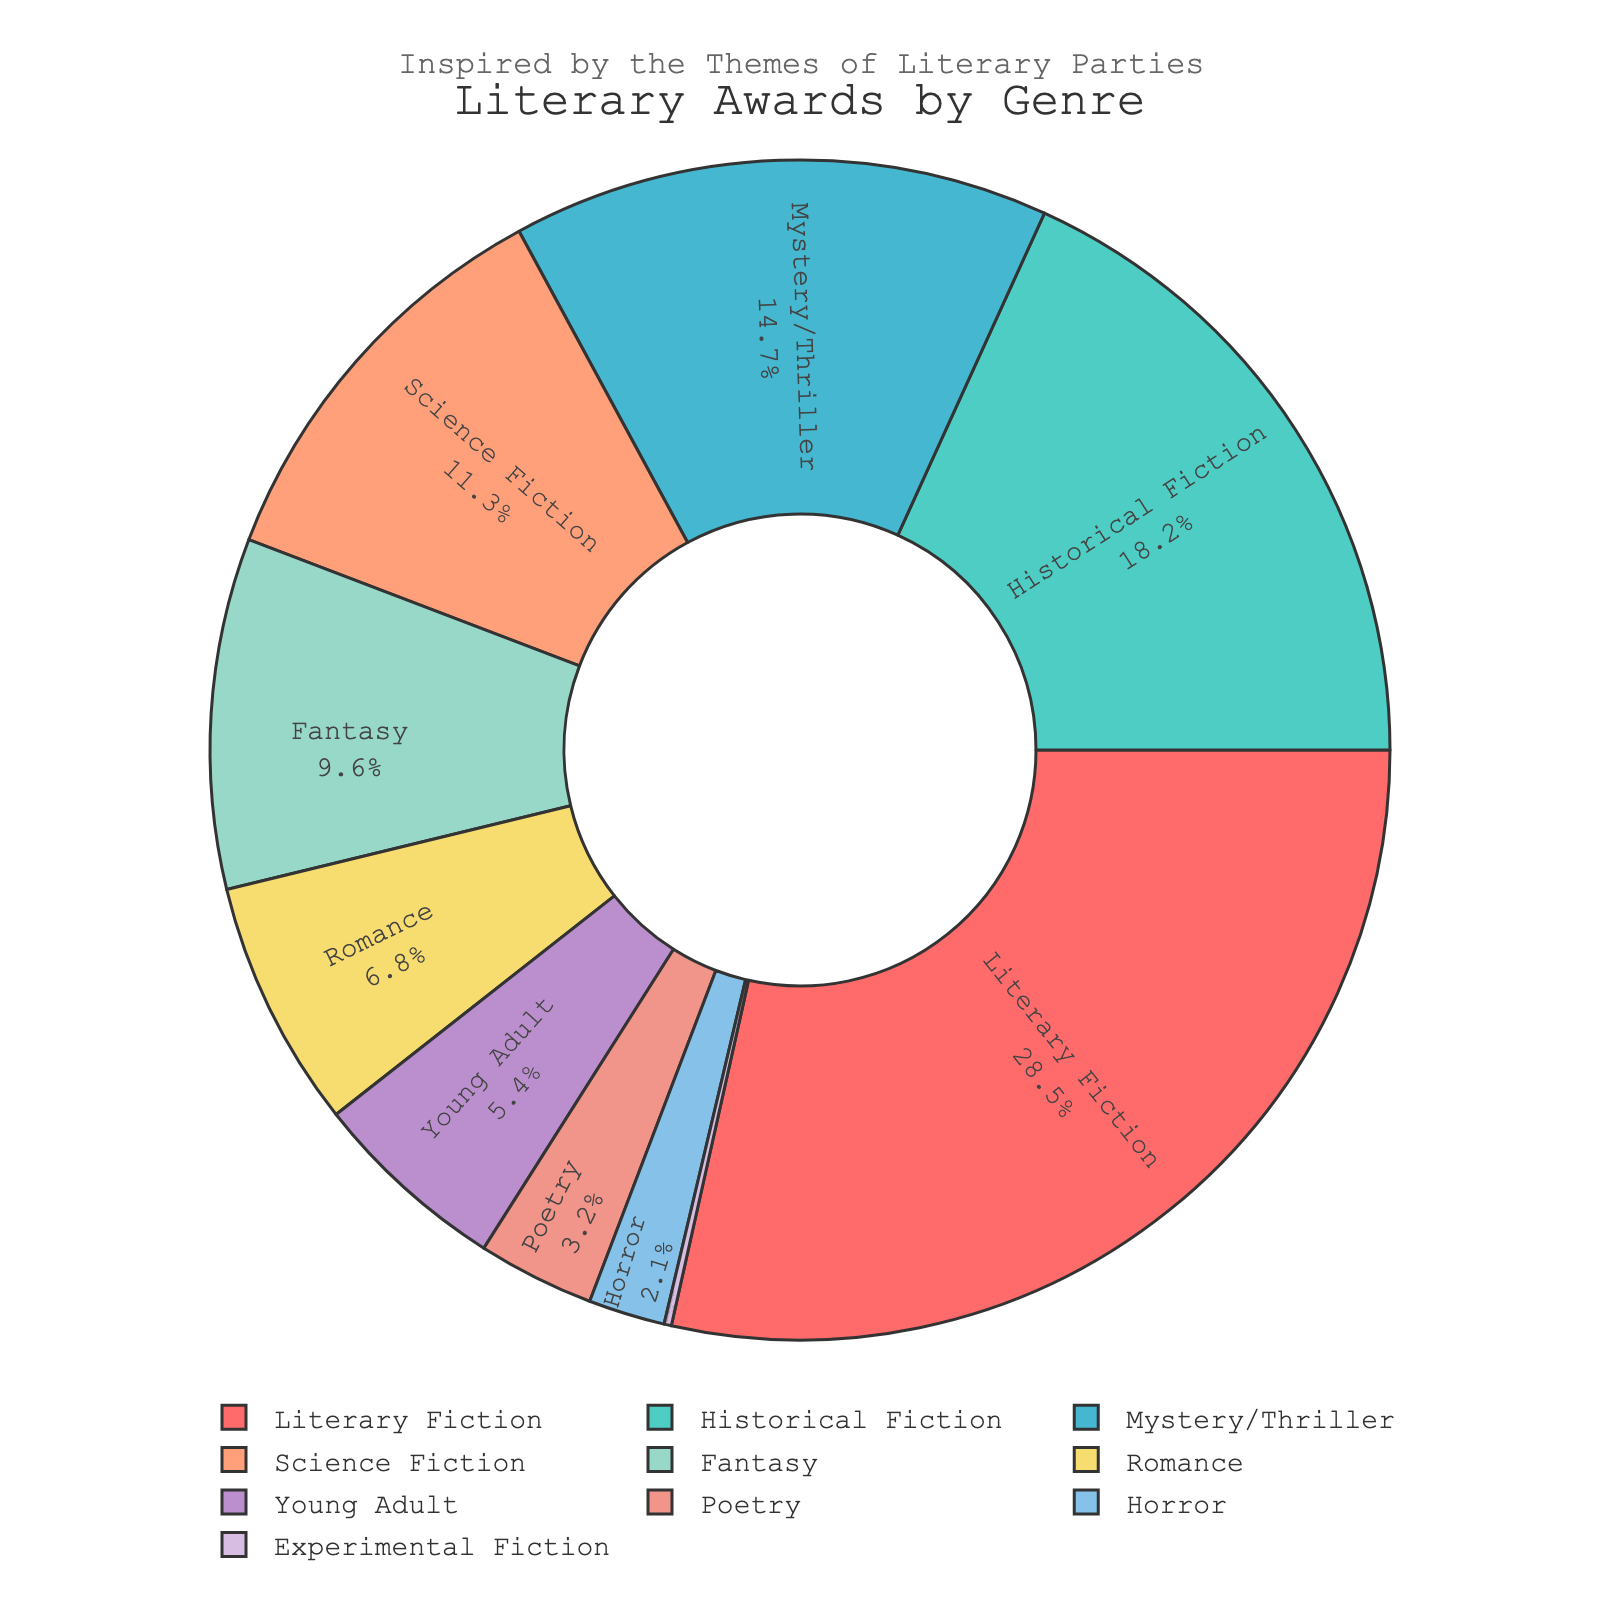what genre has the highest percentage of literary awards? By looking at the pie chart, the segment with the largest size corresponds to the genre with the highest percentage. The label indicates this is "Literary Fiction" with 28.5%.
Answer: Literary Fiction which genre categories have a percentage greater than 10%? By observing the pie chart, the genres with individual percentages shown to be higher than 10% are "Literary Fiction" (28.5%), "Historical Fiction" (18.2%), "Mystery/Thriller" (14.7%), and "Science Fiction" (11.3%).
Answer: Literary Fiction, Historical Fiction, Mystery/Thriller, Science Fiction how does the percentage of Fantasy compare to Science Fiction? Compare the labeled percentages on the pie chart: "Fantasy" has 9.6%, while "Science Fiction" has 11.3%. Thus, "Science Fiction" has a higher percentage.
Answer: Science Fiction is higher what is the total percentage for genres with less than 10%? We need to sum the percentages of Fantasy (9.6%), Romance (6.8%), Young Adult (5.4%), Poetry (3.2%), Horror (2.1%), and Experimental Fiction (0.2%). The sum is 9.6 + 6.8 + 5.4 + 3.2 + 2.1 + 0.2 = 27.3%.
Answer: 27.3% what genres collectively hold nearly half the pie chart? Nearly half the pie chart would be around 50%. The genres "Literary Fiction" (28.5%) and "Historical Fiction" (18.2%) together sum to 28.5 + 18.2 = 46.7%, which is close to half.
Answer: Literary Fiction and Historical Fiction which genre has the smallest proportion of literary awards? Look at the smallest segment of the pie chart or the label indicating the smallest percentage. "Experimental Fiction" has the smallest percentage at 0.2%.
Answer: Experimental Fiction what is the difference in percentage between Young Adult and Poetry? Identify the percentages for "Young Adult" (5.4%) and "Poetry" (3.2%), and calculate the difference: 5.4 - 3.2 = 2.2%.
Answer: 2.2% how many genres have a percentage smaller than 5%? Count the segments with percentages less than 5%: "Poetry" (3.2%), "Horror" (2.1%), and "Experimental Fiction" (0.2%). There are three such genres.
Answer: 3 genres 